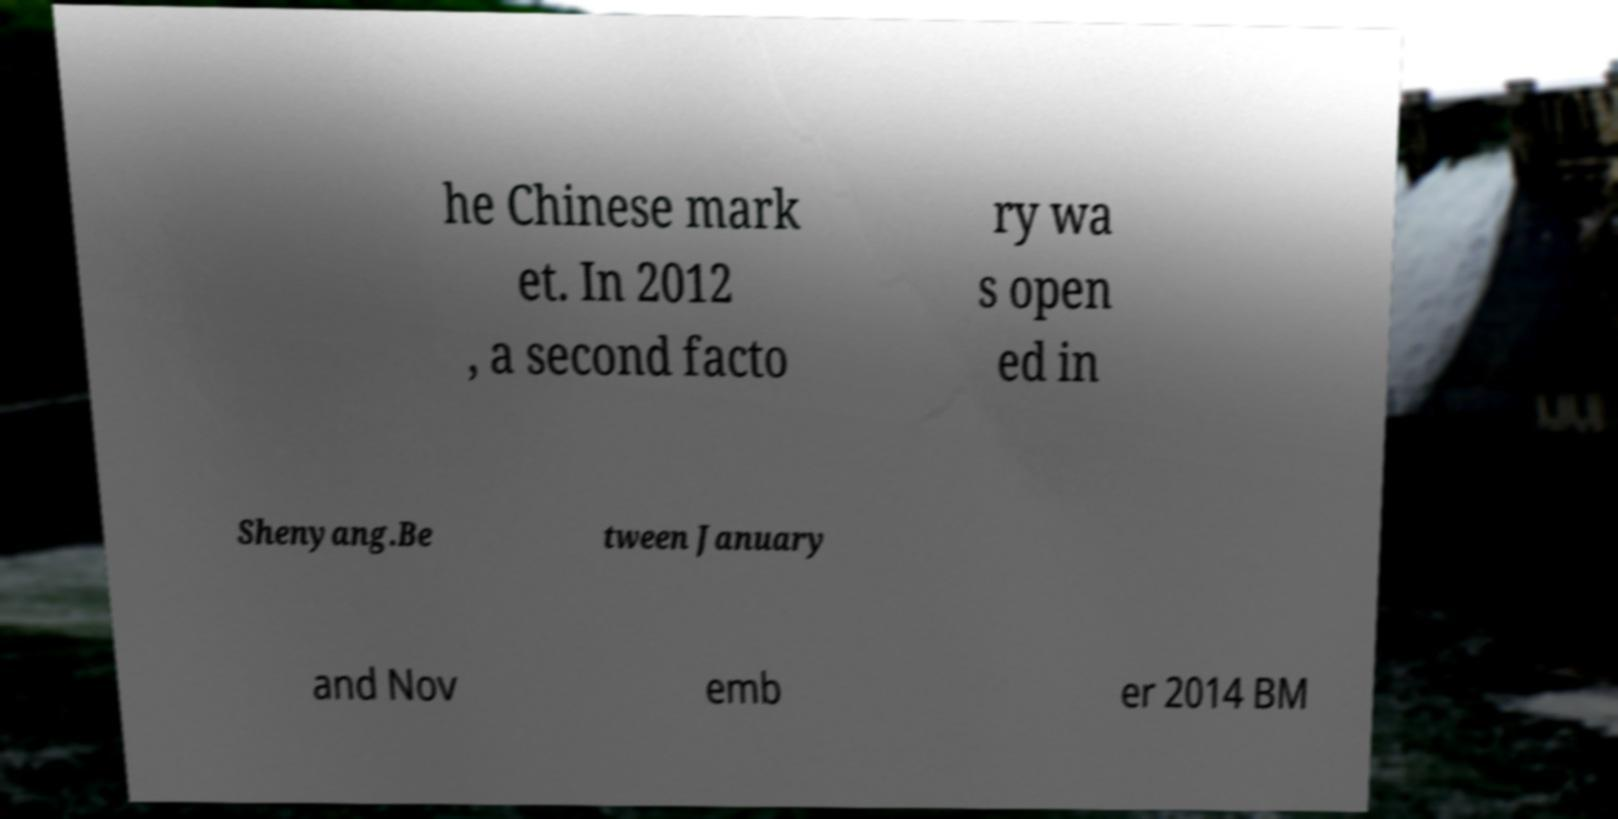Can you read and provide the text displayed in the image?This photo seems to have some interesting text. Can you extract and type it out for me? he Chinese mark et. In 2012 , a second facto ry wa s open ed in Shenyang.Be tween January and Nov emb er 2014 BM 